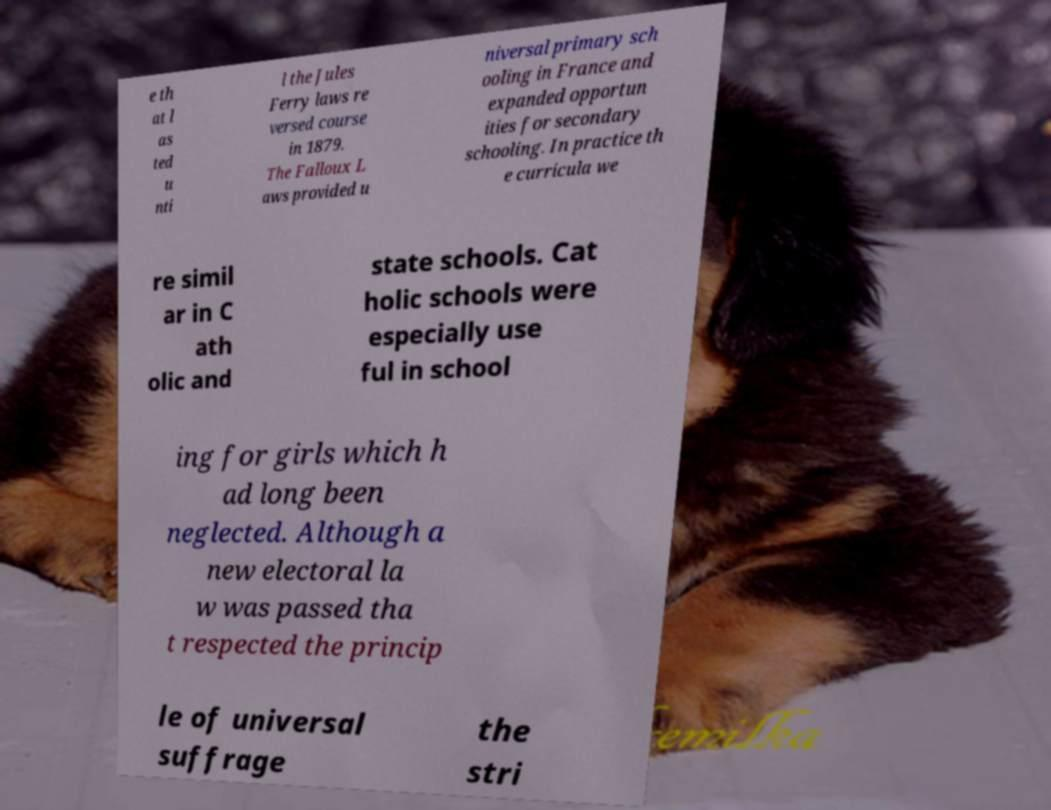I need the written content from this picture converted into text. Can you do that? e th at l as ted u nti l the Jules Ferry laws re versed course in 1879. The Falloux L aws provided u niversal primary sch ooling in France and expanded opportun ities for secondary schooling. In practice th e curricula we re simil ar in C ath olic and state schools. Cat holic schools were especially use ful in school ing for girls which h ad long been neglected. Although a new electoral la w was passed tha t respected the princip le of universal suffrage the stri 